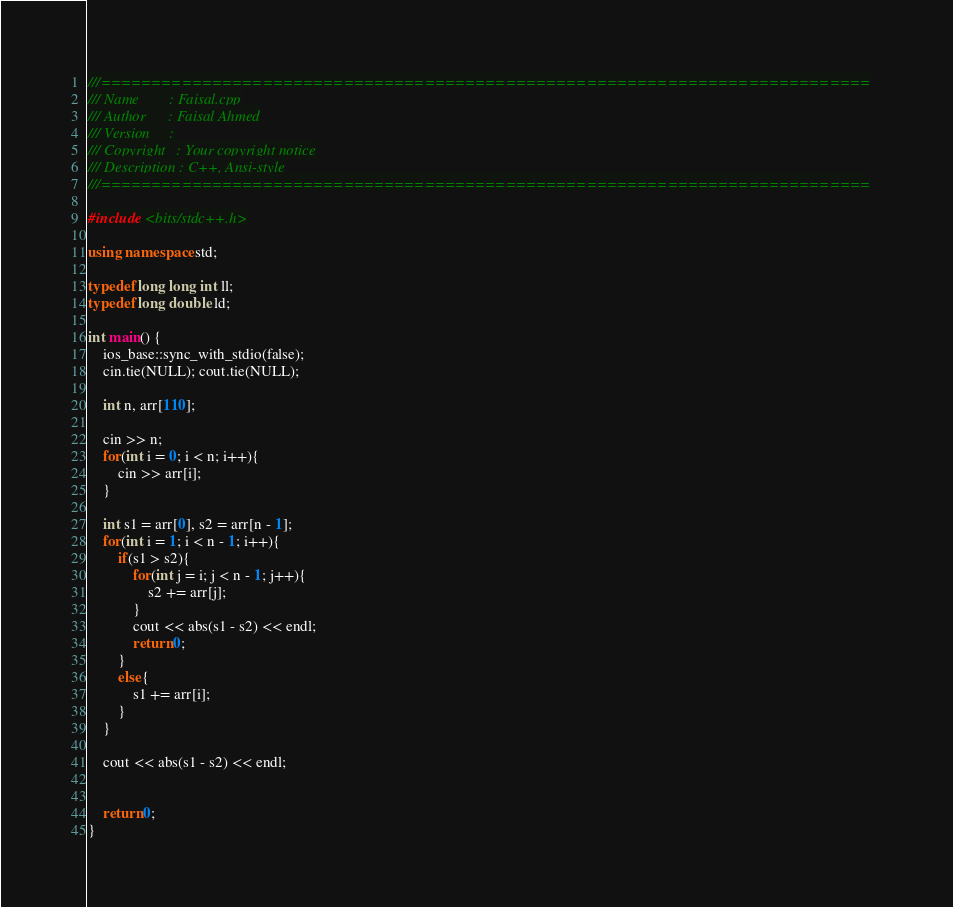<code> <loc_0><loc_0><loc_500><loc_500><_C++_>///============================================================================
/// Name        : Faisal.cpp
/// Author      : Faisal Ahmed
/// Version     :
/// Copyright   : Your copyright notice
/// Description : C++, Ansi-style
///============================================================================

#include <bits/stdc++.h>

using namespace std;

typedef long long int ll;
typedef long double ld;

int main() {
	ios_base::sync_with_stdio(false);
	cin.tie(NULL); cout.tie(NULL);

	int n, arr[110];

	cin >> n;
	for(int i = 0; i < n; i++){
        cin >> arr[i];
	}

	int s1 = arr[0], s2 = arr[n - 1];
    for(int i = 1; i < n - 1; i++){
        if(s1 > s2){
            for(int j = i; j < n - 1; j++){
                s2 += arr[j];
            }
            cout << abs(s1 - s2) << endl;
            return 0;
        }
        else{
            s1 += arr[i];
        }
    }

    cout << abs(s1 - s2) << endl;


	return 0;
}

</code> 